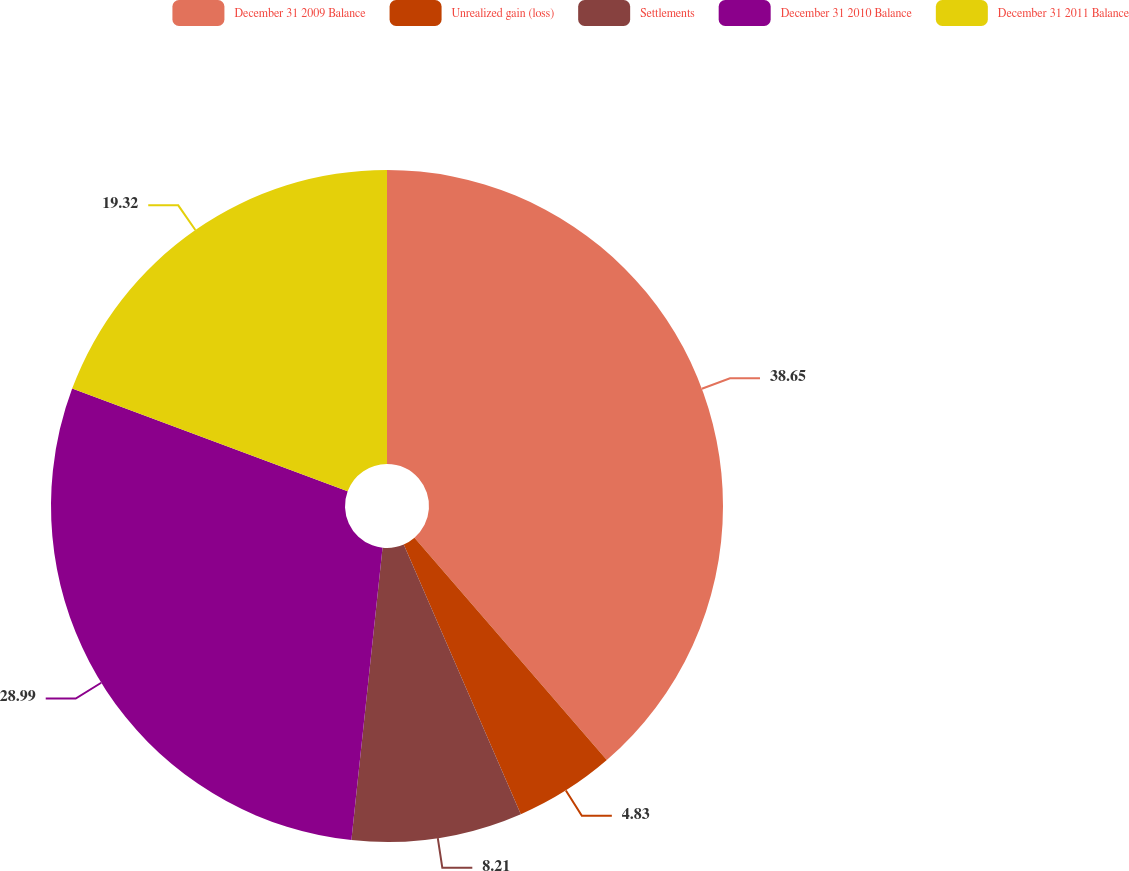Convert chart. <chart><loc_0><loc_0><loc_500><loc_500><pie_chart><fcel>December 31 2009 Balance<fcel>Unrealized gain (loss)<fcel>Settlements<fcel>December 31 2010 Balance<fcel>December 31 2011 Balance<nl><fcel>38.65%<fcel>4.83%<fcel>8.21%<fcel>28.99%<fcel>19.32%<nl></chart> 